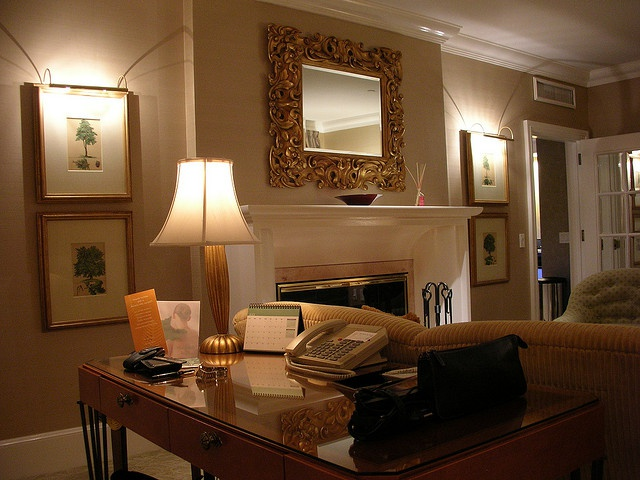Describe the objects in this image and their specific colors. I can see dining table in maroon, black, and gray tones, couch in maroon, black, and brown tones, handbag in maroon, black, brown, and gray tones, handbag in maroon, black, and gray tones, and couch in maroon, black, and gray tones in this image. 